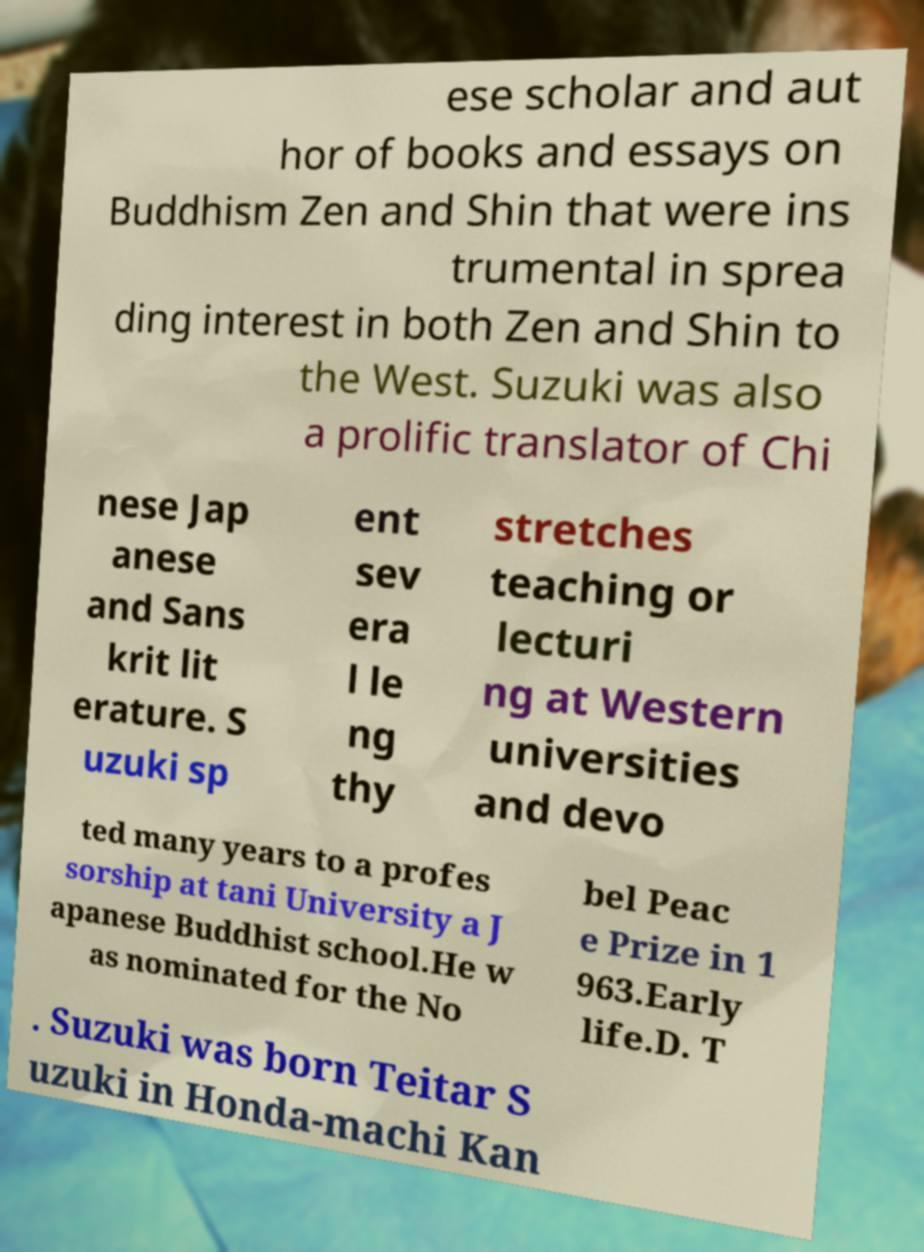What messages or text are displayed in this image? I need them in a readable, typed format. ese scholar and aut hor of books and essays on Buddhism Zen and Shin that were ins trumental in sprea ding interest in both Zen and Shin to the West. Suzuki was also a prolific translator of Chi nese Jap anese and Sans krit lit erature. S uzuki sp ent sev era l le ng thy stretches teaching or lecturi ng at Western universities and devo ted many years to a profes sorship at tani University a J apanese Buddhist school.He w as nominated for the No bel Peac e Prize in 1 963.Early life.D. T . Suzuki was born Teitar S uzuki in Honda-machi Kan 